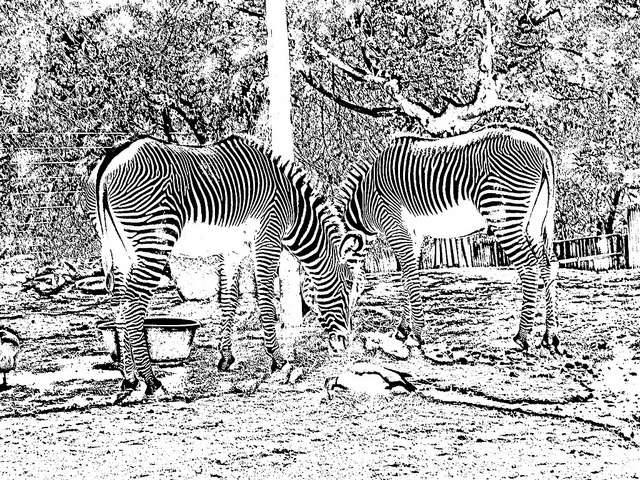Describe the objects in this image and their specific colors. I can see zebra in darkgray, white, black, and gray tones, zebra in darkgray, white, black, and gray tones, and bowl in darkgray, white, black, and gray tones in this image. 